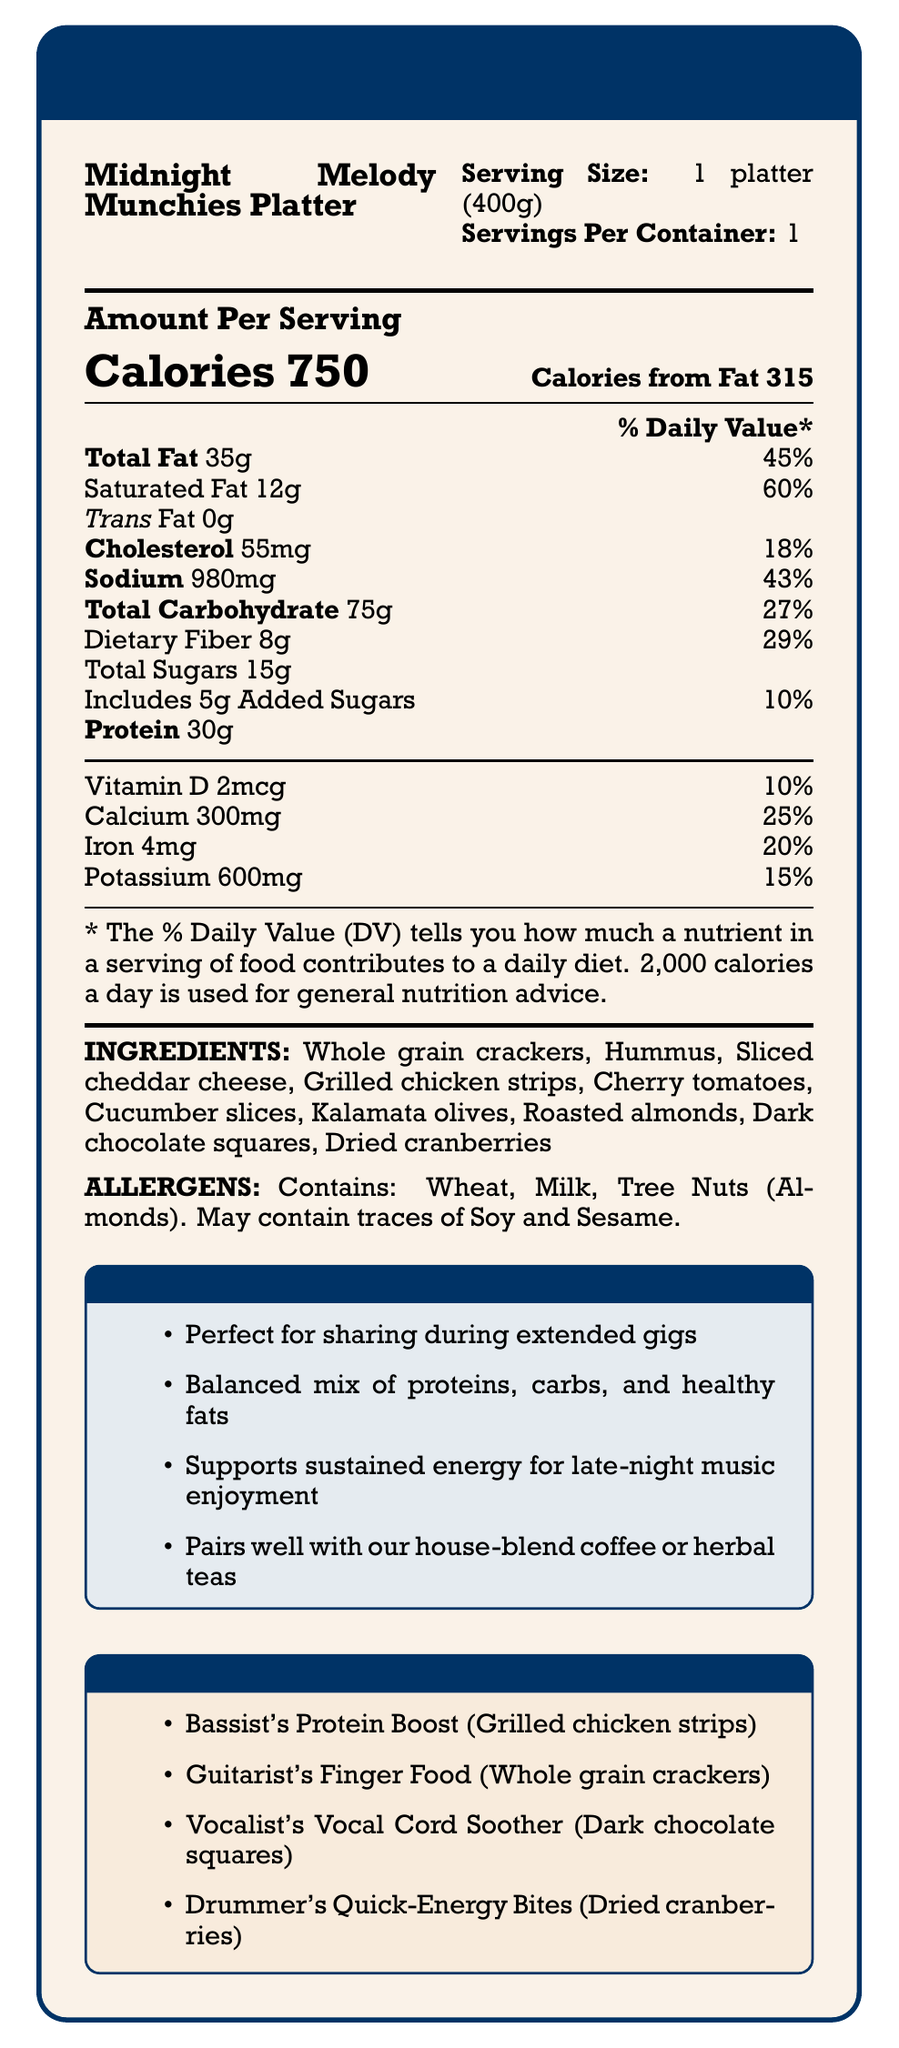What is the serving size for the Midnight Melody Munchies Platter? The document specifies that the serving size is 1 platter, and it weighs 400 grams.
Answer: 1 platter (400g) How many calories are in one serving of the Midnight Melody Munchies Platter? The document states that the platter contains 750 calories per serving.
Answer: 750 calories What is the percentage of the daily value of total fat in the platter? The document lists the total fat as 35g, which is 45% of the daily value.
Answer: 45% Does the Midnight Melody Munchies Platter contain any trans fat? The document explicitly states that the trans fat amount is 0g.
Answer: No Which ingredients in the platter may cause an allergic reaction to someone allergic to tree nuts? The allergens section in the document mentions that the platter contains tree nuts and specifies almonds.
Answer: Roasted almonds What is the calcium content in one serving of the Midnight Melody Munchies Platter? A. 10% B. 25% C. 15% D. 20% The document indicates that the calcium content is 300mg, which is 25% of the daily value.
Answer: B. 25% Which of the following ingredients is listed under "Musician's Choice" for vocalists? A. Grilled chicken strips B. Dark chocolate squares C. Whole grain crackers D. Dried cranberries The "Musician's Choice" section specifies "Vocalist's Vocal Cord Soother" as Dark chocolate squares.
Answer: B. Dark chocolate squares Does the platter support sustained energy for late-night music enjoyment according to the cafe notes? One of the cafe notes states that the platter supports sustained energy for late-night music enjoyment.
Answer: Yes Can you determine if the platter is gluten-free? There is not enough information to determine if the platter is gluten-free as the document lists wheat as an allergen but does not specify if all components are gluten-free.
Answer: No What is the main idea of the document? The document focuses on presenting comprehensive nutritional information, ingredient details, and special notes for the platter, making it suitable for customers enjoying late-night gigs.
Answer: The document provides detailed nutritional information for the Midnight Melody Munchies Platter, including serving size, calories, macronutrient content, vitamins, minerals, ingredients, allergens, and special notes from the cafe. How many grams of dietary fiber are there per serving? The document indicates that each serving contains 8 grams of dietary fiber.
Answer: 8g What amount of Vitamin D does the platter provide in terms of daily value percentage? The document lists Vitamin D at 2mcg, which accounts for 10% of the daily value.
Answer: 10% How many grams of added sugars does the product contain? According to the document, the Midnight Melody Munchies Platter includes 5 grams of added sugars, which is 10% of the daily value.
Answer: 5g Which ingredient is not explicitly categorized under a musician's choice? A. Dried cranberries B. Grilled chicken strips C. Hummus D. Whole grain crackers Hummus is listed in the ingredients but is not included in the "Musician's Choice" section.
Answer: C. Hummus What percentage of the daily value for sodium does the platter contain? The document specifies that the platter contains 980mg of sodium, which is 43% of the daily value.
Answer: 43% 